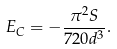<formula> <loc_0><loc_0><loc_500><loc_500>E _ { C } = - \frac { \pi ^ { 2 } S } { 7 2 0 d ^ { 3 } } .</formula> 